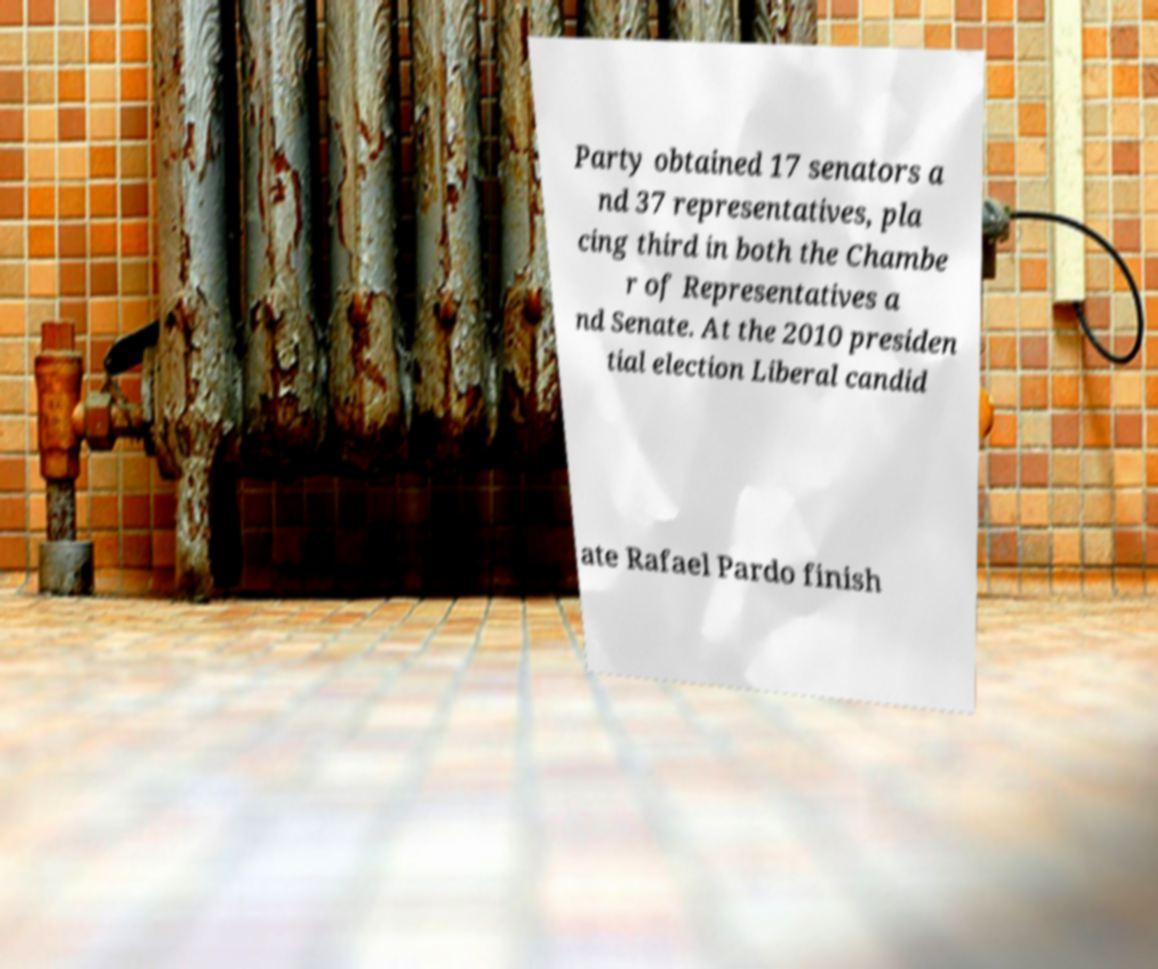What messages or text are displayed in this image? I need them in a readable, typed format. Party obtained 17 senators a nd 37 representatives, pla cing third in both the Chambe r of Representatives a nd Senate. At the 2010 presiden tial election Liberal candid ate Rafael Pardo finish 